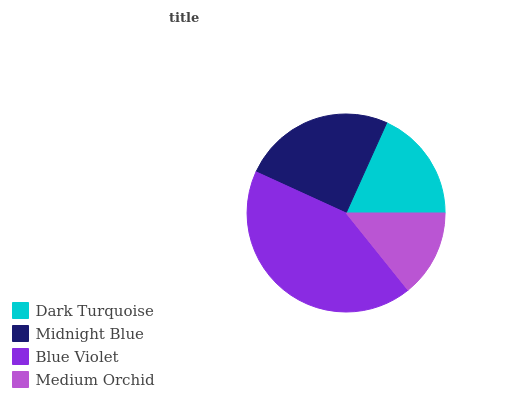Is Medium Orchid the minimum?
Answer yes or no. Yes. Is Blue Violet the maximum?
Answer yes or no. Yes. Is Midnight Blue the minimum?
Answer yes or no. No. Is Midnight Blue the maximum?
Answer yes or no. No. Is Midnight Blue greater than Dark Turquoise?
Answer yes or no. Yes. Is Dark Turquoise less than Midnight Blue?
Answer yes or no. Yes. Is Dark Turquoise greater than Midnight Blue?
Answer yes or no. No. Is Midnight Blue less than Dark Turquoise?
Answer yes or no. No. Is Midnight Blue the high median?
Answer yes or no. Yes. Is Dark Turquoise the low median?
Answer yes or no. Yes. Is Medium Orchid the high median?
Answer yes or no. No. Is Midnight Blue the low median?
Answer yes or no. No. 